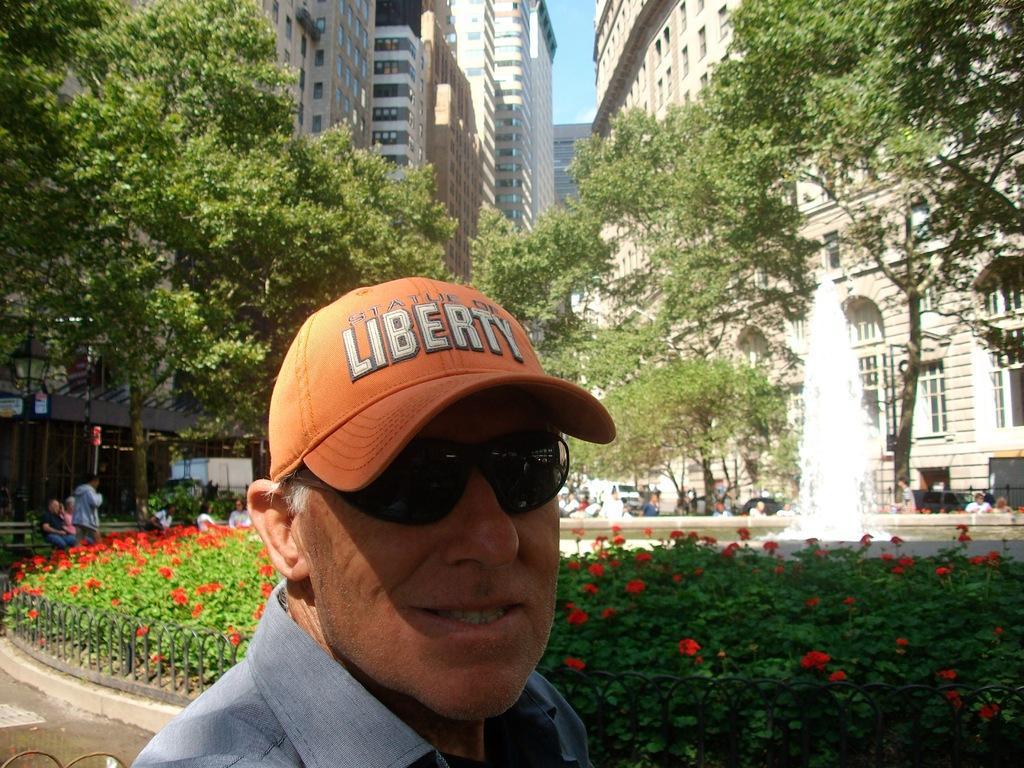In one or two sentences, can you explain what this image depicts? A man is looking at his side, he wore shirt, spectacles, cap. Behind there are flower plants, there are trees in the middle of an image. At the top there are buildings. 